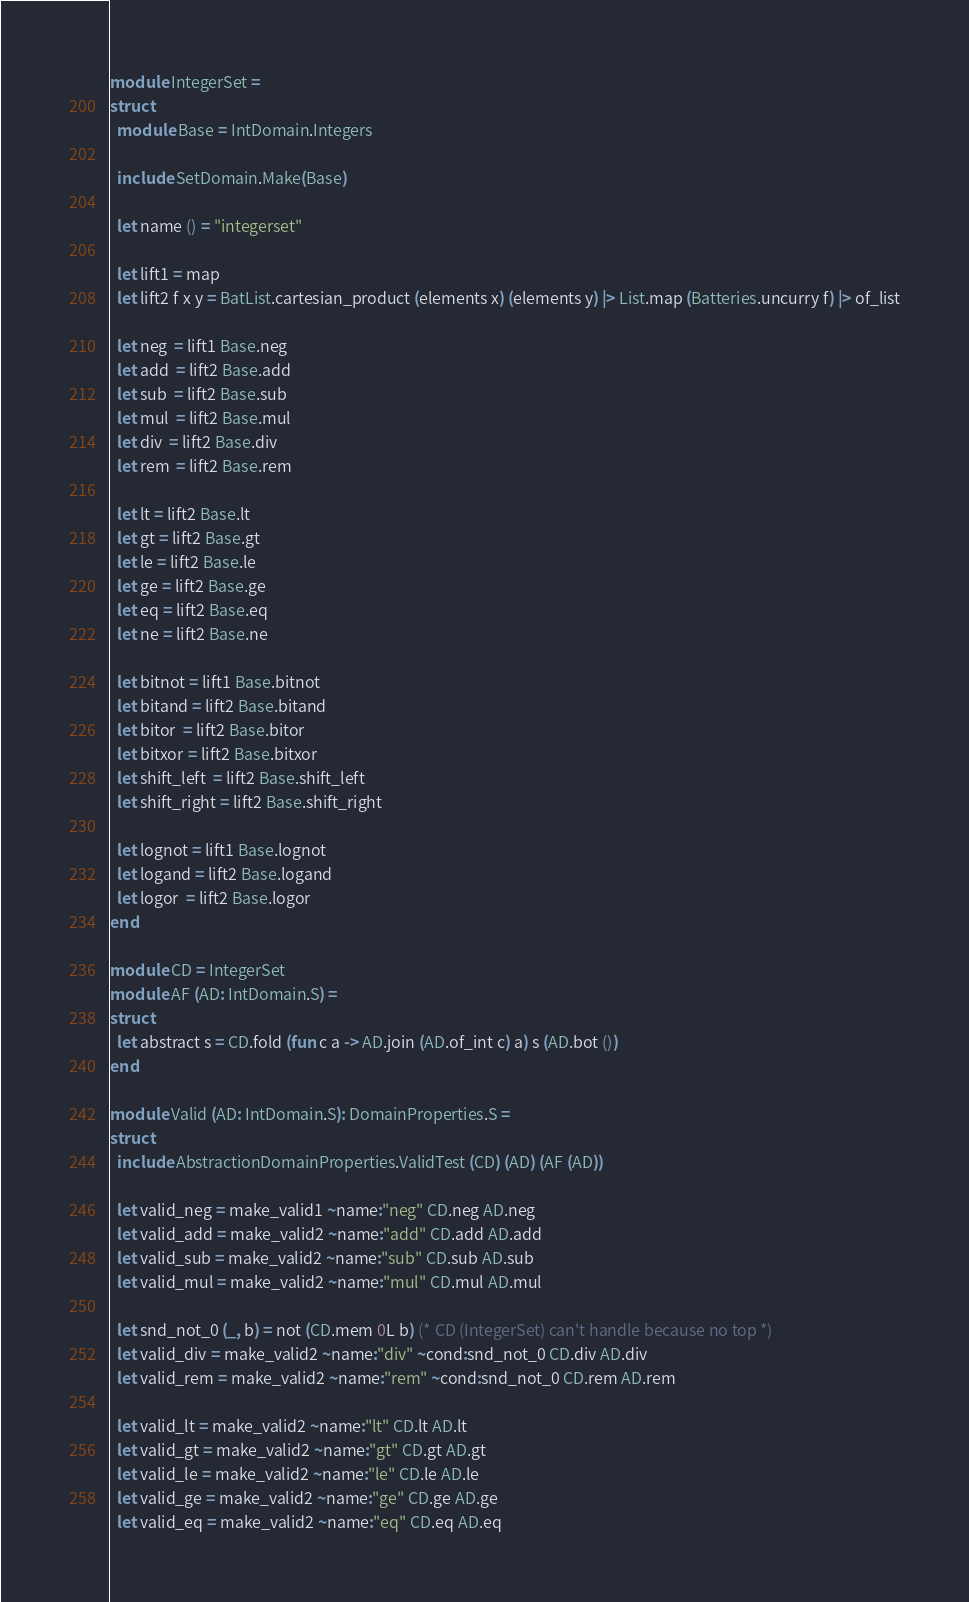Convert code to text. <code><loc_0><loc_0><loc_500><loc_500><_OCaml_>module IntegerSet =
struct
  module Base = IntDomain.Integers

  include SetDomain.Make(Base)

  let name () = "integerset"

  let lift1 = map
  let lift2 f x y = BatList.cartesian_product (elements x) (elements y) |> List.map (Batteries.uncurry f) |> of_list

  let neg  = lift1 Base.neg
  let add  = lift2 Base.add
  let sub  = lift2 Base.sub
  let mul  = lift2 Base.mul
  let div  = lift2 Base.div
  let rem  = lift2 Base.rem

  let lt = lift2 Base.lt
  let gt = lift2 Base.gt
  let le = lift2 Base.le
  let ge = lift2 Base.ge
  let eq = lift2 Base.eq
  let ne = lift2 Base.ne

  let bitnot = lift1 Base.bitnot
  let bitand = lift2 Base.bitand
  let bitor  = lift2 Base.bitor
  let bitxor = lift2 Base.bitxor
  let shift_left  = lift2 Base.shift_left
  let shift_right = lift2 Base.shift_right

  let lognot = lift1 Base.lognot
  let logand = lift2 Base.logand
  let logor  = lift2 Base.logor
end

module CD = IntegerSet
module AF (AD: IntDomain.S) =
struct
  let abstract s = CD.fold (fun c a -> AD.join (AD.of_int c) a) s (AD.bot ())
end

module Valid (AD: IntDomain.S): DomainProperties.S =
struct
  include AbstractionDomainProperties.ValidTest (CD) (AD) (AF (AD))

  let valid_neg = make_valid1 ~name:"neg" CD.neg AD.neg
  let valid_add = make_valid2 ~name:"add" CD.add AD.add
  let valid_sub = make_valid2 ~name:"sub" CD.sub AD.sub
  let valid_mul = make_valid2 ~name:"mul" CD.mul AD.mul

  let snd_not_0 (_, b) = not (CD.mem 0L b) (* CD (IntegerSet) can't handle because no top *)
  let valid_div = make_valid2 ~name:"div" ~cond:snd_not_0 CD.div AD.div
  let valid_rem = make_valid2 ~name:"rem" ~cond:snd_not_0 CD.rem AD.rem

  let valid_lt = make_valid2 ~name:"lt" CD.lt AD.lt
  let valid_gt = make_valid2 ~name:"gt" CD.gt AD.gt
  let valid_le = make_valid2 ~name:"le" CD.le AD.le
  let valid_ge = make_valid2 ~name:"ge" CD.ge AD.ge
  let valid_eq = make_valid2 ~name:"eq" CD.eq AD.eq</code> 